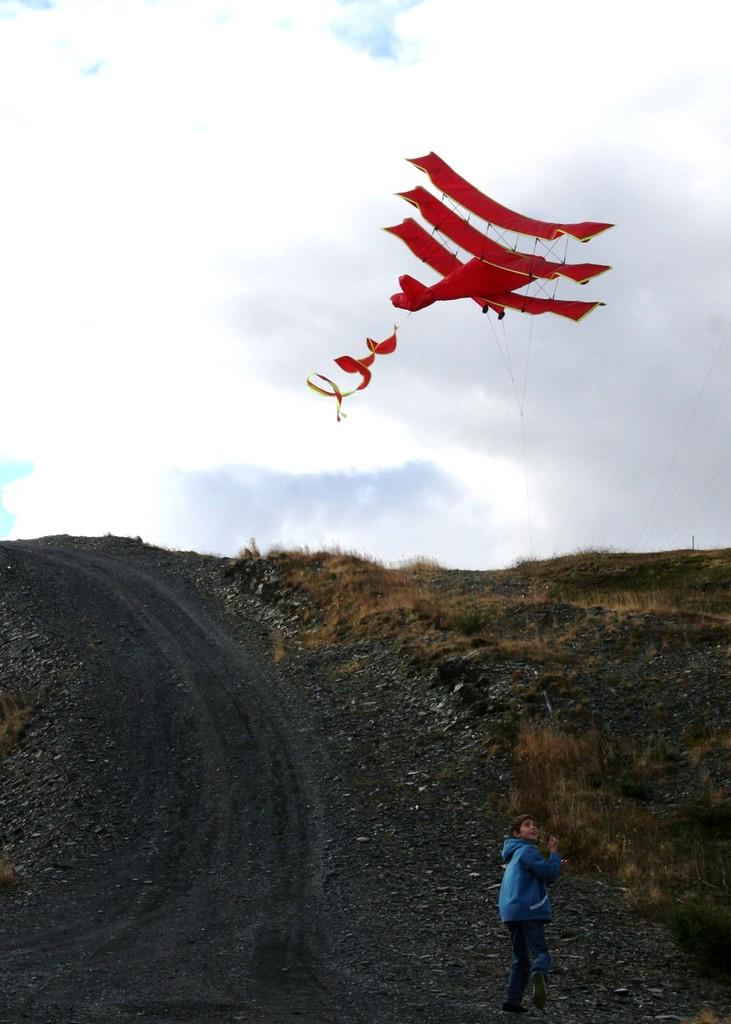Who is the main subject in the image? There is a boy in the image. What is the boy doing in the image? The boy is flying a kite with a thread. What type of terrain is visible in the image? There is grass visible in the image, and there are also stones present. What kind of surface can be seen in the image? There is a pathway in the image. How would you describe the sky in the image? The sky is visible in the image and appears cloudy. How many beggars are visible in the image? There are no beggars present in the image. What type of top is the boy wearing in the image? The image does not provide information about the boy's clothing, so we cannot determine if he is wearing a top. Are there any giants visible in the image? There are no giants present in the image. 